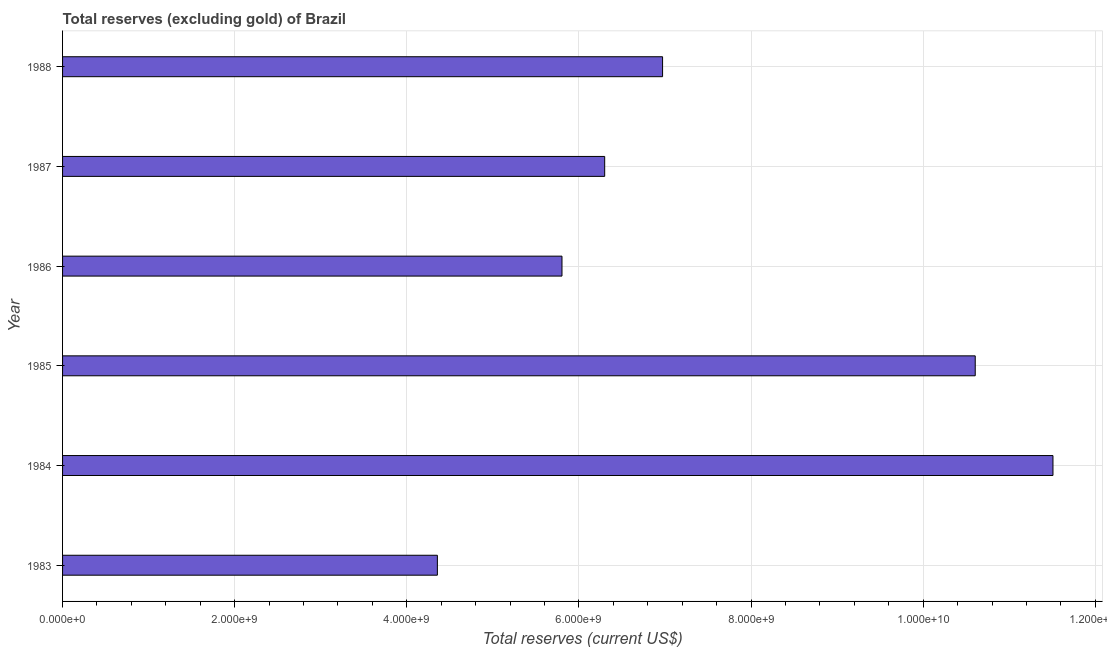What is the title of the graph?
Ensure brevity in your answer.  Total reserves (excluding gold) of Brazil. What is the label or title of the X-axis?
Your response must be concise. Total reserves (current US$). What is the label or title of the Y-axis?
Your response must be concise. Year. What is the total reserves (excluding gold) in 1988?
Your answer should be compact. 6.97e+09. Across all years, what is the maximum total reserves (excluding gold)?
Your answer should be very brief. 1.15e+1. Across all years, what is the minimum total reserves (excluding gold)?
Provide a succinct answer. 4.36e+09. In which year was the total reserves (excluding gold) maximum?
Your answer should be compact. 1984. In which year was the total reserves (excluding gold) minimum?
Provide a succinct answer. 1983. What is the sum of the total reserves (excluding gold)?
Ensure brevity in your answer.  4.55e+1. What is the difference between the total reserves (excluding gold) in 1986 and 1988?
Your answer should be compact. -1.17e+09. What is the average total reserves (excluding gold) per year?
Provide a succinct answer. 7.59e+09. What is the median total reserves (excluding gold)?
Your response must be concise. 6.64e+09. In how many years, is the total reserves (excluding gold) greater than 5600000000 US$?
Make the answer very short. 5. Do a majority of the years between 1986 and 1985 (inclusive) have total reserves (excluding gold) greater than 3600000000 US$?
Keep it short and to the point. No. What is the ratio of the total reserves (excluding gold) in 1983 to that in 1985?
Offer a very short reply. 0.41. Is the total reserves (excluding gold) in 1984 less than that in 1986?
Provide a succinct answer. No. What is the difference between the highest and the second highest total reserves (excluding gold)?
Your answer should be compact. 9.03e+08. Is the sum of the total reserves (excluding gold) in 1985 and 1987 greater than the maximum total reserves (excluding gold) across all years?
Keep it short and to the point. Yes. What is the difference between the highest and the lowest total reserves (excluding gold)?
Offer a very short reply. 7.15e+09. Are all the bars in the graph horizontal?
Your answer should be very brief. Yes. What is the difference between two consecutive major ticks on the X-axis?
Your answer should be compact. 2.00e+09. What is the Total reserves (current US$) of 1983?
Provide a succinct answer. 4.36e+09. What is the Total reserves (current US$) in 1984?
Give a very brief answer. 1.15e+1. What is the Total reserves (current US$) of 1985?
Ensure brevity in your answer.  1.06e+1. What is the Total reserves (current US$) of 1986?
Your answer should be very brief. 5.80e+09. What is the Total reserves (current US$) of 1987?
Offer a terse response. 6.30e+09. What is the Total reserves (current US$) in 1988?
Provide a short and direct response. 6.97e+09. What is the difference between the Total reserves (current US$) in 1983 and 1984?
Your response must be concise. -7.15e+09. What is the difference between the Total reserves (current US$) in 1983 and 1985?
Give a very brief answer. -6.25e+09. What is the difference between the Total reserves (current US$) in 1983 and 1986?
Your response must be concise. -1.45e+09. What is the difference between the Total reserves (current US$) in 1983 and 1987?
Make the answer very short. -1.94e+09. What is the difference between the Total reserves (current US$) in 1983 and 1988?
Your answer should be compact. -2.62e+09. What is the difference between the Total reserves (current US$) in 1984 and 1985?
Your answer should be compact. 9.03e+08. What is the difference between the Total reserves (current US$) in 1984 and 1986?
Give a very brief answer. 5.70e+09. What is the difference between the Total reserves (current US$) in 1984 and 1987?
Give a very brief answer. 5.21e+09. What is the difference between the Total reserves (current US$) in 1984 and 1988?
Provide a short and direct response. 4.54e+09. What is the difference between the Total reserves (current US$) in 1985 and 1986?
Make the answer very short. 4.80e+09. What is the difference between the Total reserves (current US$) in 1985 and 1987?
Ensure brevity in your answer.  4.31e+09. What is the difference between the Total reserves (current US$) in 1985 and 1988?
Your response must be concise. 3.63e+09. What is the difference between the Total reserves (current US$) in 1986 and 1987?
Provide a succinct answer. -4.96e+08. What is the difference between the Total reserves (current US$) in 1986 and 1988?
Your answer should be very brief. -1.17e+09. What is the difference between the Total reserves (current US$) in 1987 and 1988?
Offer a terse response. -6.73e+08. What is the ratio of the Total reserves (current US$) in 1983 to that in 1984?
Give a very brief answer. 0.38. What is the ratio of the Total reserves (current US$) in 1983 to that in 1985?
Provide a short and direct response. 0.41. What is the ratio of the Total reserves (current US$) in 1983 to that in 1986?
Give a very brief answer. 0.75. What is the ratio of the Total reserves (current US$) in 1983 to that in 1987?
Your response must be concise. 0.69. What is the ratio of the Total reserves (current US$) in 1983 to that in 1988?
Offer a terse response. 0.62. What is the ratio of the Total reserves (current US$) in 1984 to that in 1985?
Offer a very short reply. 1.08. What is the ratio of the Total reserves (current US$) in 1984 to that in 1986?
Keep it short and to the point. 1.98. What is the ratio of the Total reserves (current US$) in 1984 to that in 1987?
Ensure brevity in your answer.  1.83. What is the ratio of the Total reserves (current US$) in 1984 to that in 1988?
Provide a short and direct response. 1.65. What is the ratio of the Total reserves (current US$) in 1985 to that in 1986?
Your answer should be very brief. 1.83. What is the ratio of the Total reserves (current US$) in 1985 to that in 1987?
Your response must be concise. 1.68. What is the ratio of the Total reserves (current US$) in 1985 to that in 1988?
Provide a short and direct response. 1.52. What is the ratio of the Total reserves (current US$) in 1986 to that in 1987?
Ensure brevity in your answer.  0.92. What is the ratio of the Total reserves (current US$) in 1986 to that in 1988?
Offer a very short reply. 0.83. What is the ratio of the Total reserves (current US$) in 1987 to that in 1988?
Make the answer very short. 0.9. 